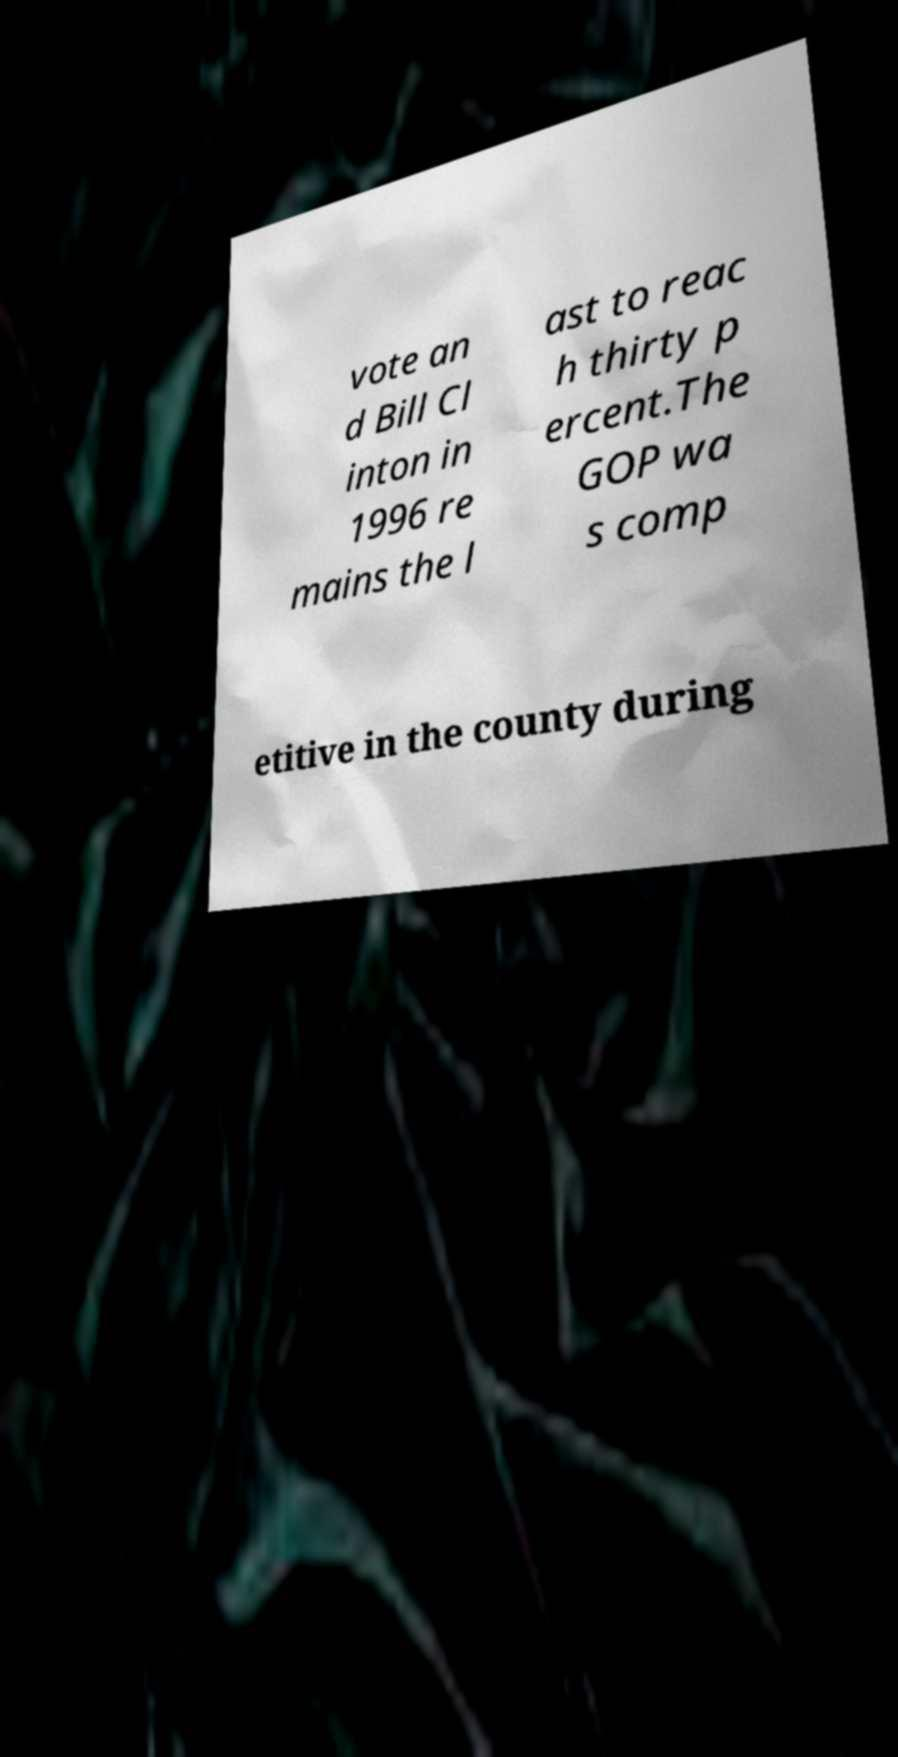Can you accurately transcribe the text from the provided image for me? vote an d Bill Cl inton in 1996 re mains the l ast to reac h thirty p ercent.The GOP wa s comp etitive in the county during 